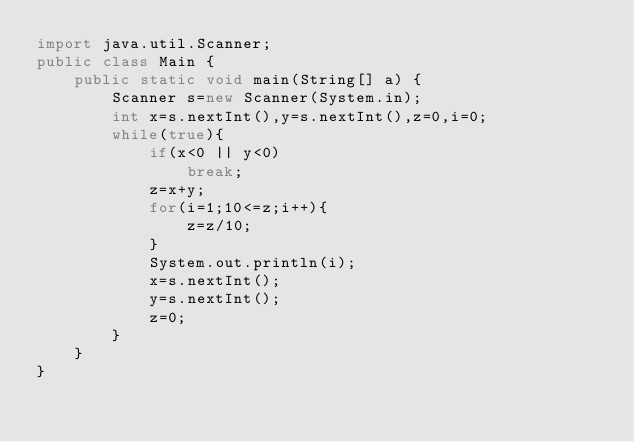<code> <loc_0><loc_0><loc_500><loc_500><_Java_>import java.util.Scanner;
public class Main {
	public static void main(String[] a) {
		Scanner s=new Scanner(System.in);
		int x=s.nextInt(),y=s.nextInt(),z=0,i=0;
		while(true){
			if(x<0 || y<0)
				break;
			z=x+y;
			for(i=1;10<=z;i++){
				z=z/10;
			}
			System.out.println(i);
			x=s.nextInt();
			y=s.nextInt();
			z=0;
		}
	}
}</code> 